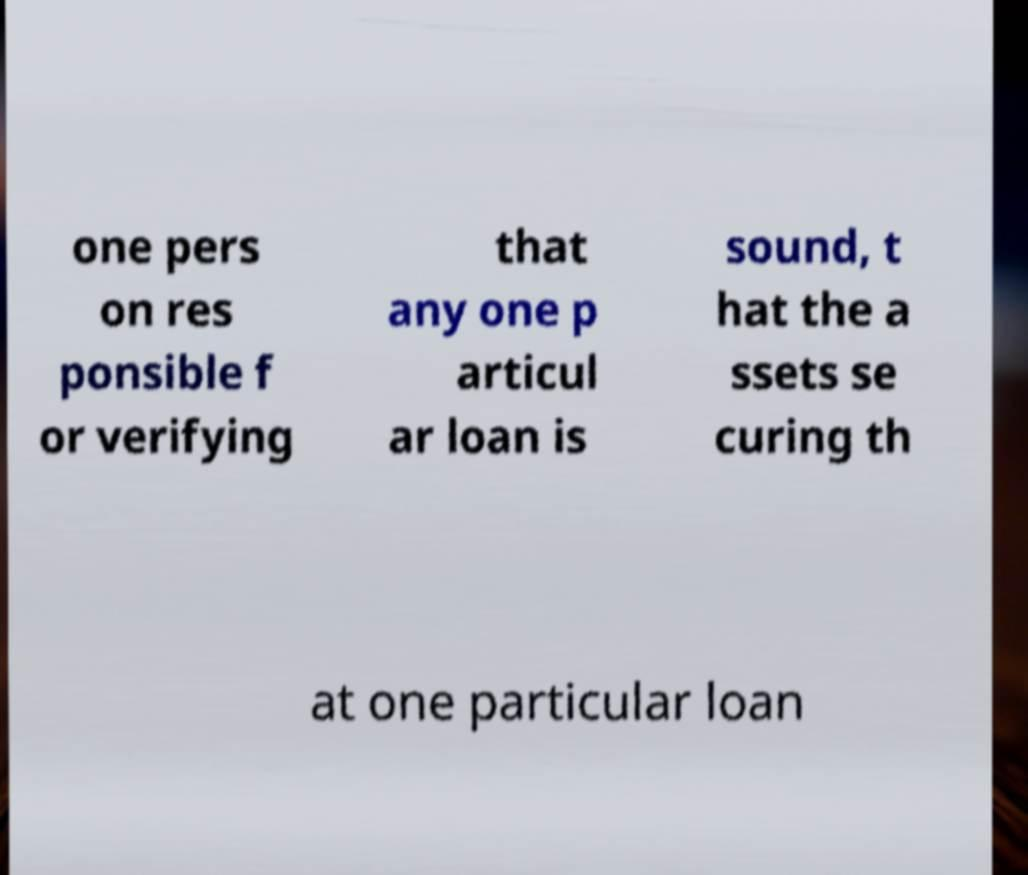Can you accurately transcribe the text from the provided image for me? one pers on res ponsible f or verifying that any one p articul ar loan is sound, t hat the a ssets se curing th at one particular loan 